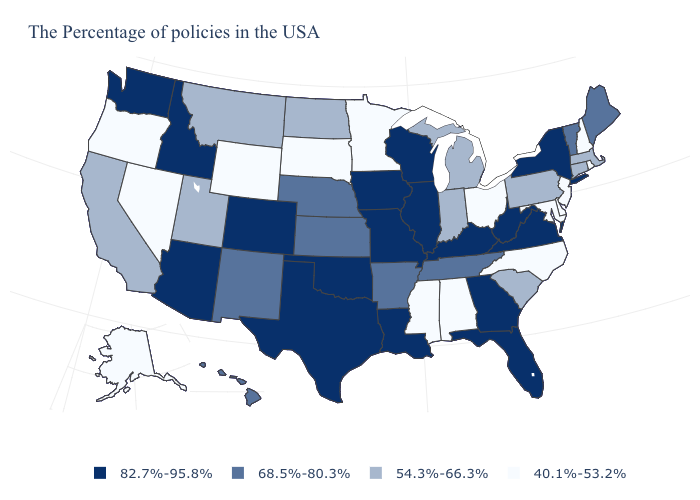What is the value of Mississippi?
Be succinct. 40.1%-53.2%. What is the value of Utah?
Be succinct. 54.3%-66.3%. Does South Dakota have the lowest value in the USA?
Short answer required. Yes. Which states have the lowest value in the USA?
Short answer required. Rhode Island, New Hampshire, New Jersey, Delaware, Maryland, North Carolina, Ohio, Alabama, Mississippi, Minnesota, South Dakota, Wyoming, Nevada, Oregon, Alaska. Among the states that border California , which have the highest value?
Quick response, please. Arizona. Is the legend a continuous bar?
Give a very brief answer. No. Which states have the highest value in the USA?
Write a very short answer. New York, Virginia, West Virginia, Florida, Georgia, Kentucky, Wisconsin, Illinois, Louisiana, Missouri, Iowa, Oklahoma, Texas, Colorado, Arizona, Idaho, Washington. What is the lowest value in the MidWest?
Short answer required. 40.1%-53.2%. What is the lowest value in states that border Rhode Island?
Be succinct. 54.3%-66.3%. Name the states that have a value in the range 68.5%-80.3%?
Concise answer only. Maine, Vermont, Tennessee, Arkansas, Kansas, Nebraska, New Mexico, Hawaii. Name the states that have a value in the range 54.3%-66.3%?
Answer briefly. Massachusetts, Connecticut, Pennsylvania, South Carolina, Michigan, Indiana, North Dakota, Utah, Montana, California. What is the lowest value in the Northeast?
Answer briefly. 40.1%-53.2%. Which states hav the highest value in the South?
Quick response, please. Virginia, West Virginia, Florida, Georgia, Kentucky, Louisiana, Oklahoma, Texas. What is the value of Wyoming?
Write a very short answer. 40.1%-53.2%. What is the value of Oklahoma?
Write a very short answer. 82.7%-95.8%. 